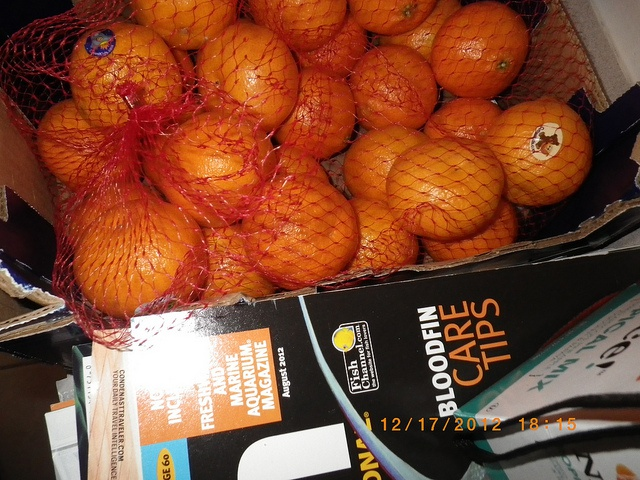Describe the objects in this image and their specific colors. I can see book in black, white, darkgray, and gray tones, orange in black, brown, maroon, and red tones, orange in black, brown, maroon, and red tones, orange in black, red, brown, and orange tones, and orange in black, brown, red, and orange tones in this image. 